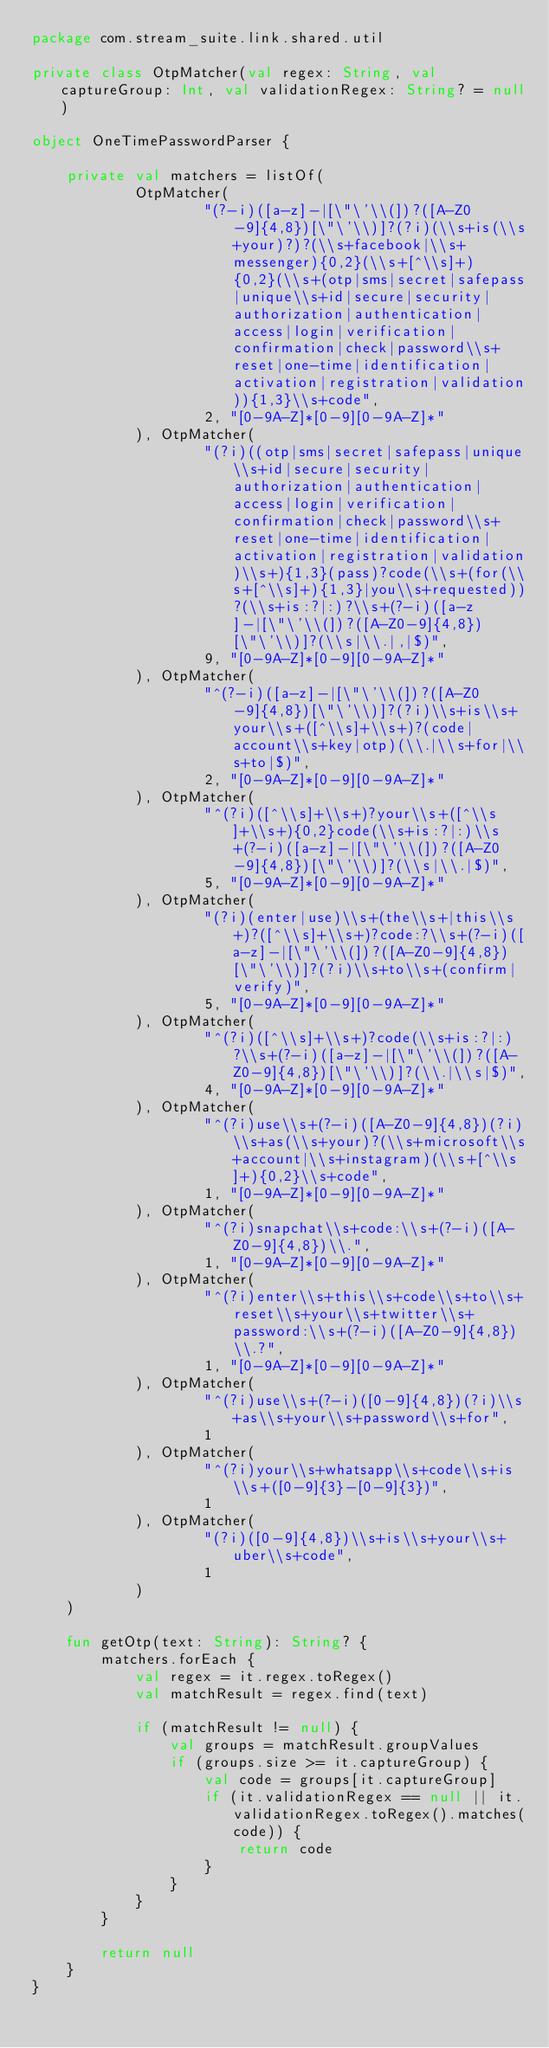Convert code to text. <code><loc_0><loc_0><loc_500><loc_500><_Kotlin_>package com.stream_suite.link.shared.util

private class OtpMatcher(val regex: String, val captureGroup: Int, val validationRegex: String? = null)

object OneTimePasswordParser {

    private val matchers = listOf(
            OtpMatcher(
                    "(?-i)([a-z]-|[\"\'\\(])?([A-Z0-9]{4,8})[\"\'\\)]?(?i)(\\s+is(\\s+your)?)?(\\s+facebook|\\s+messenger){0,2}(\\s+[^\\s]+){0,2}(\\s+(otp|sms|secret|safepass|unique\\s+id|secure|security|authorization|authentication|access|login|verification|confirmation|check|password\\s+reset|one-time|identification|activation|registration|validation)){1,3}\\s+code",
                    2, "[0-9A-Z]*[0-9][0-9A-Z]*"
            ), OtpMatcher(
                    "(?i)((otp|sms|secret|safepass|unique\\s+id|secure|security|authorization|authentication|access|login|verification|confirmation|check|password\\s+reset|one-time|identification|activation|registration|validation)\\s+){1,3}(pass)?code(\\s+(for(\\s+[^\\s]+){1,3}|you\\s+requested))?(\\s+is:?|:)?\\s+(?-i)([a-z]-|[\"\'\\(])?([A-Z0-9]{4,8})[\"\'\\)]?(\\s|\\.|,|$)",
                    9, "[0-9A-Z]*[0-9][0-9A-Z]*"
            ), OtpMatcher(
                    "^(?-i)([a-z]-|[\"\'\\(])?([A-Z0-9]{4,8})[\"\'\\)]?(?i)\\s+is\\s+your\\s+([^\\s]+\\s+)?(code|account\\s+key|otp)(\\.|\\s+for|\\s+to|$)",
                    2, "[0-9A-Z]*[0-9][0-9A-Z]*"
            ), OtpMatcher(
                    "^(?i)([^\\s]+\\s+)?your\\s+([^\\s]+\\s+){0,2}code(\\s+is:?|:)\\s+(?-i)([a-z]-|[\"\'\\(])?([A-Z0-9]{4,8})[\"\'\\)]?(\\s|\\.|$)",
                    5, "[0-9A-Z]*[0-9][0-9A-Z]*"
            ), OtpMatcher(
                    "(?i)(enter|use)\\s+(the\\s+|this\\s+)?([^\\s]+\\s+)?code:?\\s+(?-i)([a-z]-|[\"\'\\(])?([A-Z0-9]{4,8})[\"\'\\)]?(?i)\\s+to\\s+(confirm|verify)",
                    5, "[0-9A-Z]*[0-9][0-9A-Z]*"
            ), OtpMatcher(
                    "^(?i)([^\\s]+\\s+)?code(\\s+is:?|:)?\\s+(?-i)([a-z]-|[\"\'\\(])?([A-Z0-9]{4,8})[\"\'\\)]?(\\.|\\s|$)",
                    4, "[0-9A-Z]*[0-9][0-9A-Z]*"
            ), OtpMatcher(
                    "^(?i)use\\s+(?-i)([A-Z0-9]{4,8})(?i)\\s+as(\\s+your)?(\\s+microsoft\\s+account|\\s+instagram)(\\s+[^\\s]+){0,2}\\s+code",
                    1, "[0-9A-Z]*[0-9][0-9A-Z]*"
            ), OtpMatcher(
                    "^(?i)snapchat\\s+code:\\s+(?-i)([A-Z0-9]{4,8})\\.",
                    1, "[0-9A-Z]*[0-9][0-9A-Z]*"
            ), OtpMatcher(
                    "^(?i)enter\\s+this\\s+code\\s+to\\s+reset\\s+your\\s+twitter\\s+password:\\s+(?-i)([A-Z0-9]{4,8})\\.?",
                    1, "[0-9A-Z]*[0-9][0-9A-Z]*"
            ), OtpMatcher(
                    "^(?i)use\\s+(?-i)([0-9]{4,8})(?i)\\s+as\\s+your\\s+password\\s+for",
                    1
            ), OtpMatcher(
                    "^(?i)your\\s+whatsapp\\s+code\\s+is\\s+([0-9]{3}-[0-9]{3})",
                    1
            ), OtpMatcher(
                    "(?i)([0-9]{4,8})\\s+is\\s+your\\s+uber\\s+code",
                    1
            )
    )

    fun getOtp(text: String): String? {
        matchers.forEach {
            val regex = it.regex.toRegex()
            val matchResult = regex.find(text)

            if (matchResult != null) {
                val groups = matchResult.groupValues
                if (groups.size >= it.captureGroup) {
                    val code = groups[it.captureGroup]
                    if (it.validationRegex == null || it.validationRegex.toRegex().matches(code)) {
                        return code
                    }
                }
            }
        }

        return null
    }
}</code> 